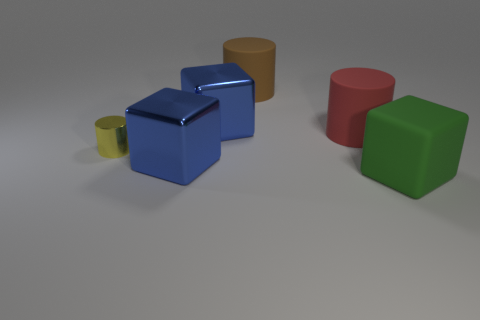Add 2 big purple cylinders. How many objects exist? 8 Add 2 tiny yellow metal objects. How many tiny yellow metal objects are left? 3 Add 1 blue things. How many blue things exist? 3 Subtract 0 blue cylinders. How many objects are left? 6 Subtract all green rubber things. Subtract all yellow cylinders. How many objects are left? 4 